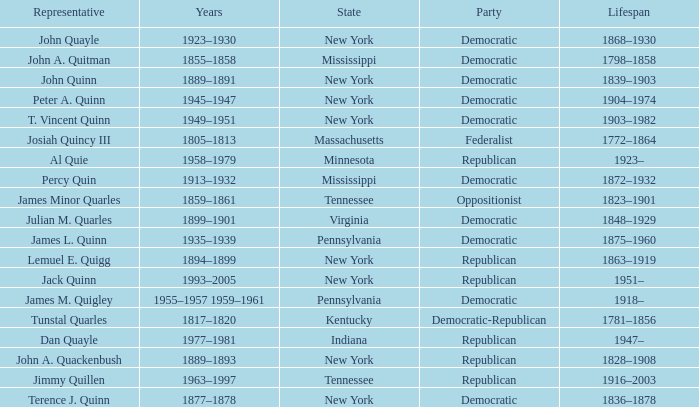Could you parse the entire table as a dict? {'header': ['Representative', 'Years', 'State', 'Party', 'Lifespan'], 'rows': [['John Quayle', '1923–1930', 'New York', 'Democratic', '1868–1930'], ['John A. Quitman', '1855–1858', 'Mississippi', 'Democratic', '1798–1858'], ['John Quinn', '1889–1891', 'New York', 'Democratic', '1839–1903'], ['Peter A. Quinn', '1945–1947', 'New York', 'Democratic', '1904–1974'], ['T. Vincent Quinn', '1949–1951', 'New York', 'Democratic', '1903–1982'], ['Josiah Quincy III', '1805–1813', 'Massachusetts', 'Federalist', '1772–1864'], ['Al Quie', '1958–1979', 'Minnesota', 'Republican', '1923–'], ['Percy Quin', '1913–1932', 'Mississippi', 'Democratic', '1872–1932'], ['James Minor Quarles', '1859–1861', 'Tennessee', 'Oppositionist', '1823–1901'], ['Julian M. Quarles', '1899–1901', 'Virginia', 'Democratic', '1848–1929'], ['James L. Quinn', '1935–1939', 'Pennsylvania', 'Democratic', '1875–1960'], ['Lemuel E. Quigg', '1894–1899', 'New York', 'Republican', '1863–1919'], ['Jack Quinn', '1993–2005', 'New York', 'Republican', '1951–'], ['James M. Quigley', '1955–1957 1959–1961', 'Pennsylvania', 'Democratic', '1918–'], ['Tunstal Quarles', '1817–1820', 'Kentucky', 'Democratic-Republican', '1781–1856'], ['Dan Quayle', '1977–1981', 'Indiana', 'Republican', '1947–'], ['John A. Quackenbush', '1889–1893', 'New York', 'Republican', '1828–1908'], ['Jimmy Quillen', '1963–1997', 'Tennessee', 'Republican', '1916–2003'], ['Terence J. Quinn', '1877–1878', 'New York', 'Democratic', '1836–1878']]} Which state does Jimmy Quillen represent? Tennessee. 